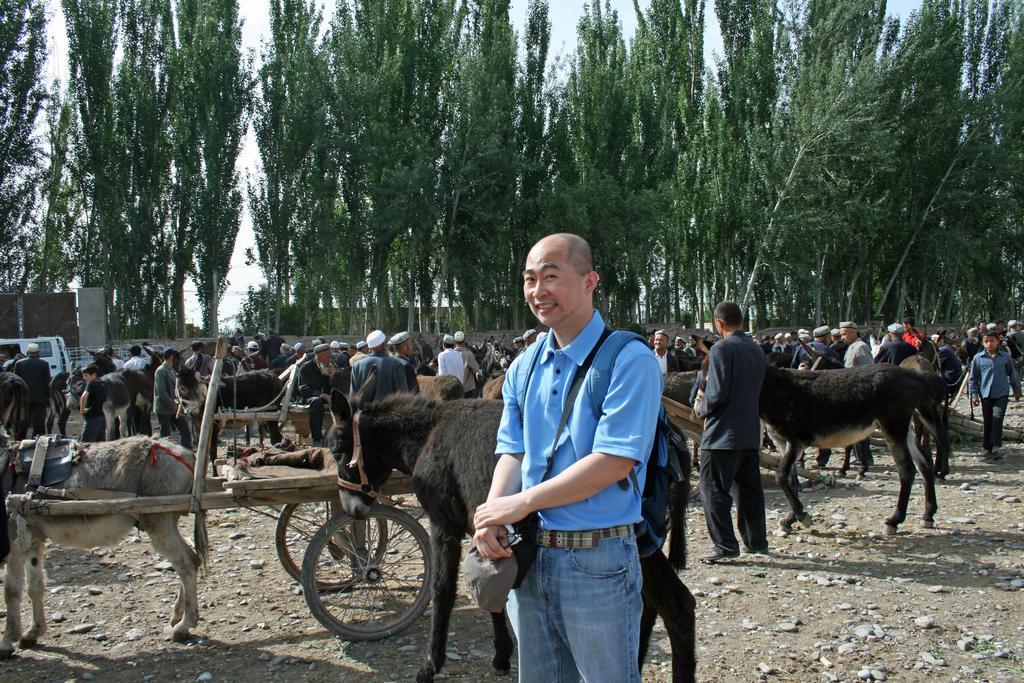Can you describe this image briefly? In this image there is a person standing, in the background there are donkey carts and there are people, in the background there is a wall and trees. 